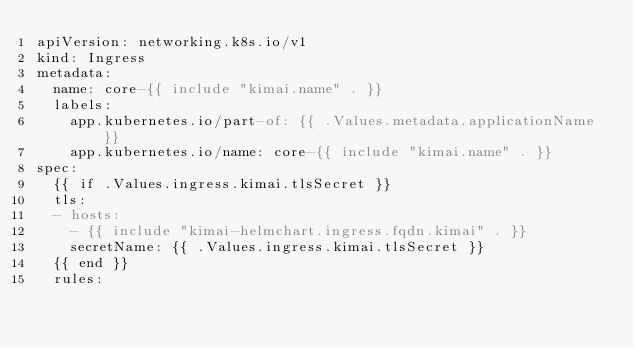Convert code to text. <code><loc_0><loc_0><loc_500><loc_500><_YAML_>apiVersion: networking.k8s.io/v1
kind: Ingress
metadata:
  name: core-{{ include "kimai.name" . }}
  labels:
    app.kubernetes.io/part-of: {{ .Values.metadata.applicationName }}
    app.kubernetes.io/name: core-{{ include "kimai.name" . }}
spec:
  {{ if .Values.ingress.kimai.tlsSecret }}
  tls:
  - hosts:
    - {{ include "kimai-helmchart.ingress.fqdn.kimai" . }}
    secretName: {{ .Values.ingress.kimai.tlsSecret }}
  {{ end }}
  rules:</code> 